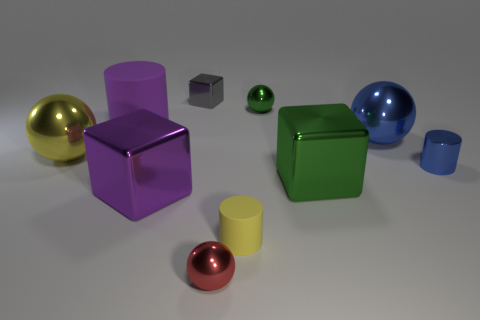Subtract all red metallic balls. How many balls are left? 3 Subtract all yellow spheres. How many spheres are left? 3 Subtract all gray spheres. Subtract all brown cylinders. How many spheres are left? 4 Subtract all balls. How many objects are left? 6 Subtract all small cylinders. Subtract all big gray matte blocks. How many objects are left? 8 Add 1 metal cylinders. How many metal cylinders are left? 2 Add 1 small purple matte cylinders. How many small purple matte cylinders exist? 1 Subtract 0 brown cubes. How many objects are left? 10 